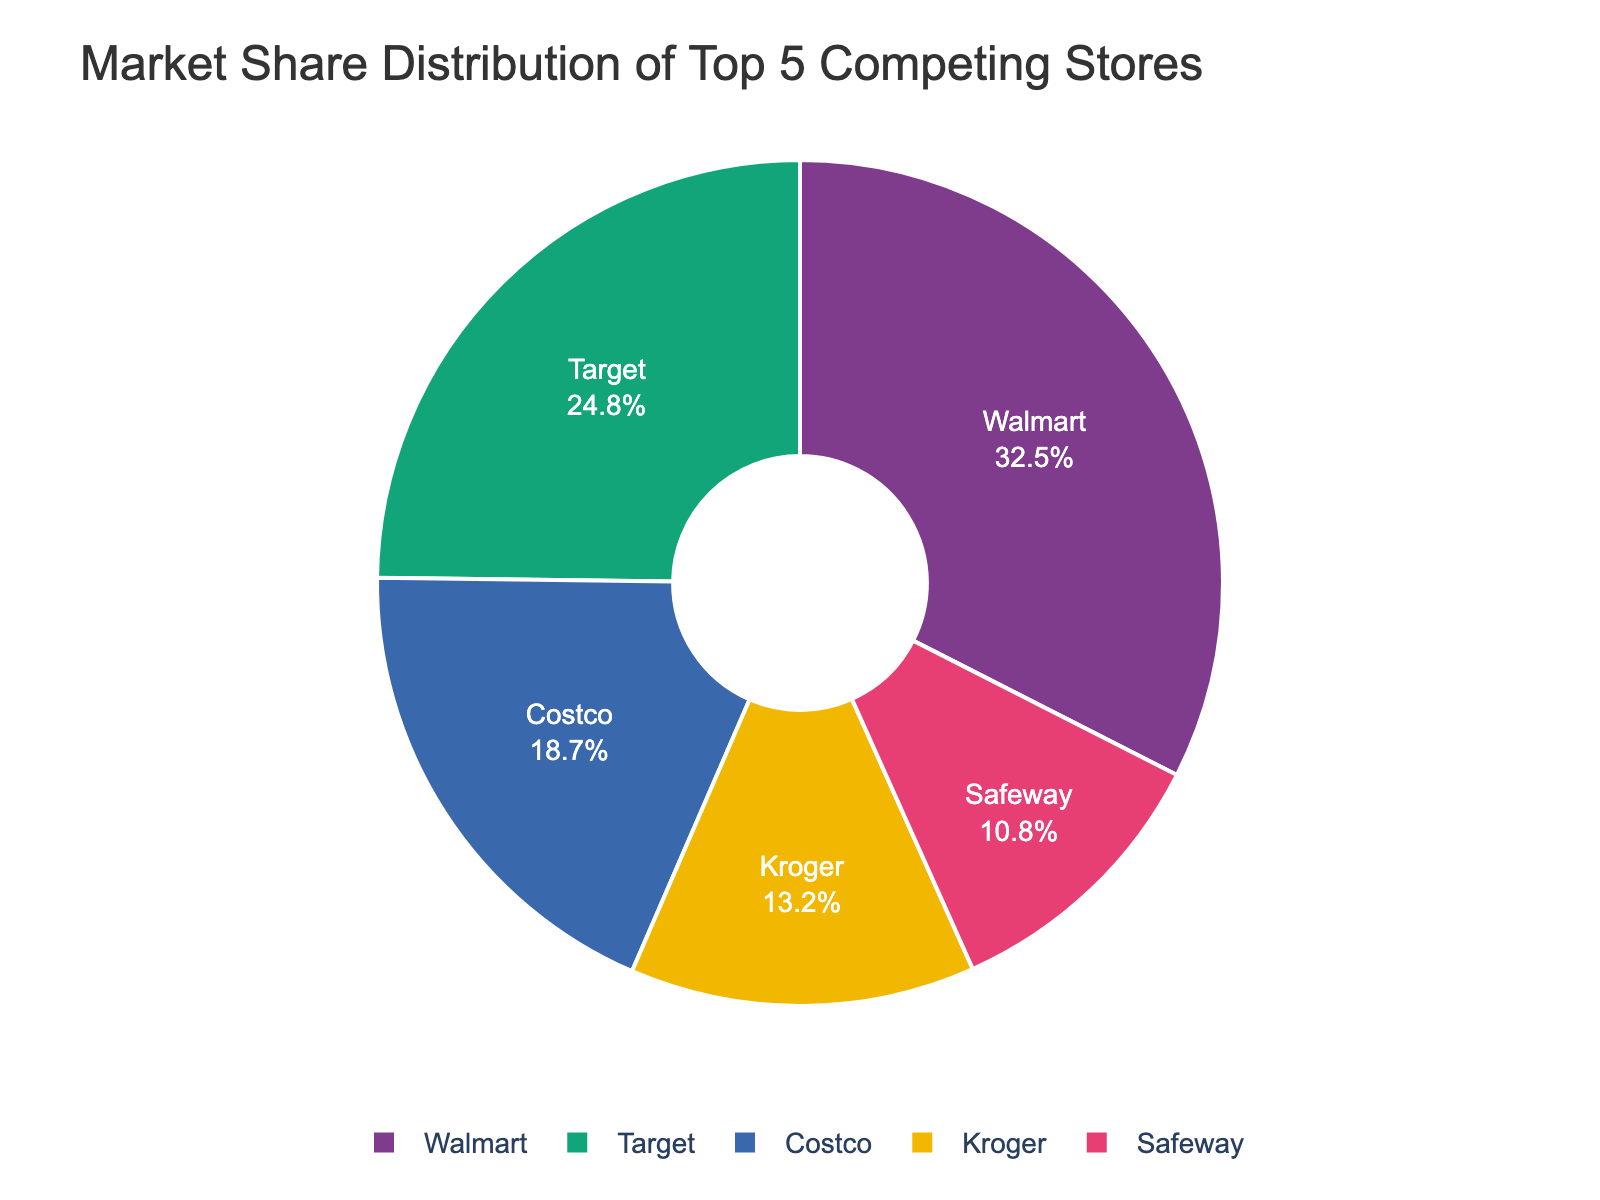What percentage of the market share does Walmart hold? Walmart holds 32.5% of the market share as indicated by the largest segment of the pie chart.
Answer: 32.5% Which store has the smallest market share? The smallest slice in the pie chart represents Safeway, which has the smallest market share of 10.8%.
Answer: Safeway What is the difference in market share between Walmart and Target? Walmart has 32.5% and Target has 24.8%. The difference is 32.5% - 24.8% = 7.7%.
Answer: 7.7% What is the combined market share of Costco and Kroger? Costco has 18.7% and Kroger has 13.2%. Adding them gives 18.7% + 13.2% = 31.9%.
Answer: 31.9% Which two stores hold the largest combined market share? The largest individual shares are Walmart (32.5%) and Target (24.8%). Their combined market share is 32.5% + 24.8% = 57.3%.
Answer: Walmart and Target What color is used to represent Safeway in the pie chart? By visually inspecting the chart, Safeway is represented by a purple-colored slice.
Answer: Purple What is the average market share of all five stores? Sum the market shares: 32.5% + 24.8% + 18.7% + 13.2% + 10.8% = 100%. Divide by 5: 100% / 5 = 20%.
Answer: 20% Is any store's market share equal to or greater than the combined market share of Costco and Kroger? Costco and Kroger have a combined market share of 31.9%. Walmart, with 32.5%, has a market share greater than this.
Answer: Yes, Walmart Which store's market share is closest to the average market share? The average market share is 20%. Costco’s market share at 18.7% is closest to 20%.
Answer: Costco Which store has a market share approximately double that of Safeway? Safeway has a market share of 10.8%. Double that is approximately 21.6%. Target, with 24.8%, is around that value.
Answer: Target 